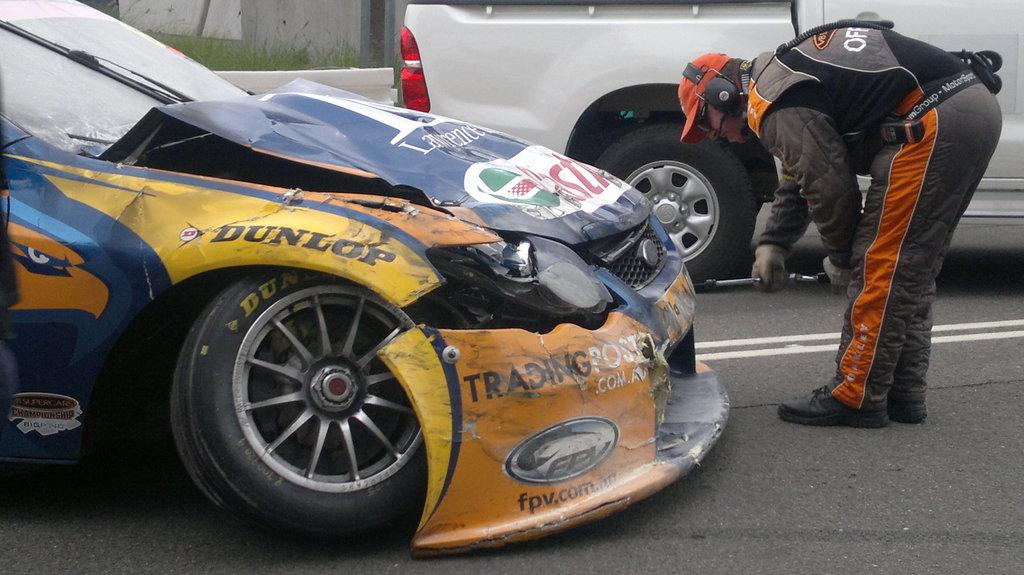What is the main subject in the foreground of the picture? There is a car in the foreground of the picture. Are there any people visible in the foreground of the picture? Yes, there is a person on the road in the foreground of the picture. What can be seen in the background of the picture? There is grass, a pole, a wall, and a vehicle in the background of the picture. What type of church can be seen in the background of the picture? There is no church present in the background of the picture. What route does the person on the road follow in the picture? The picture does not provide information about the person's route or destination. 